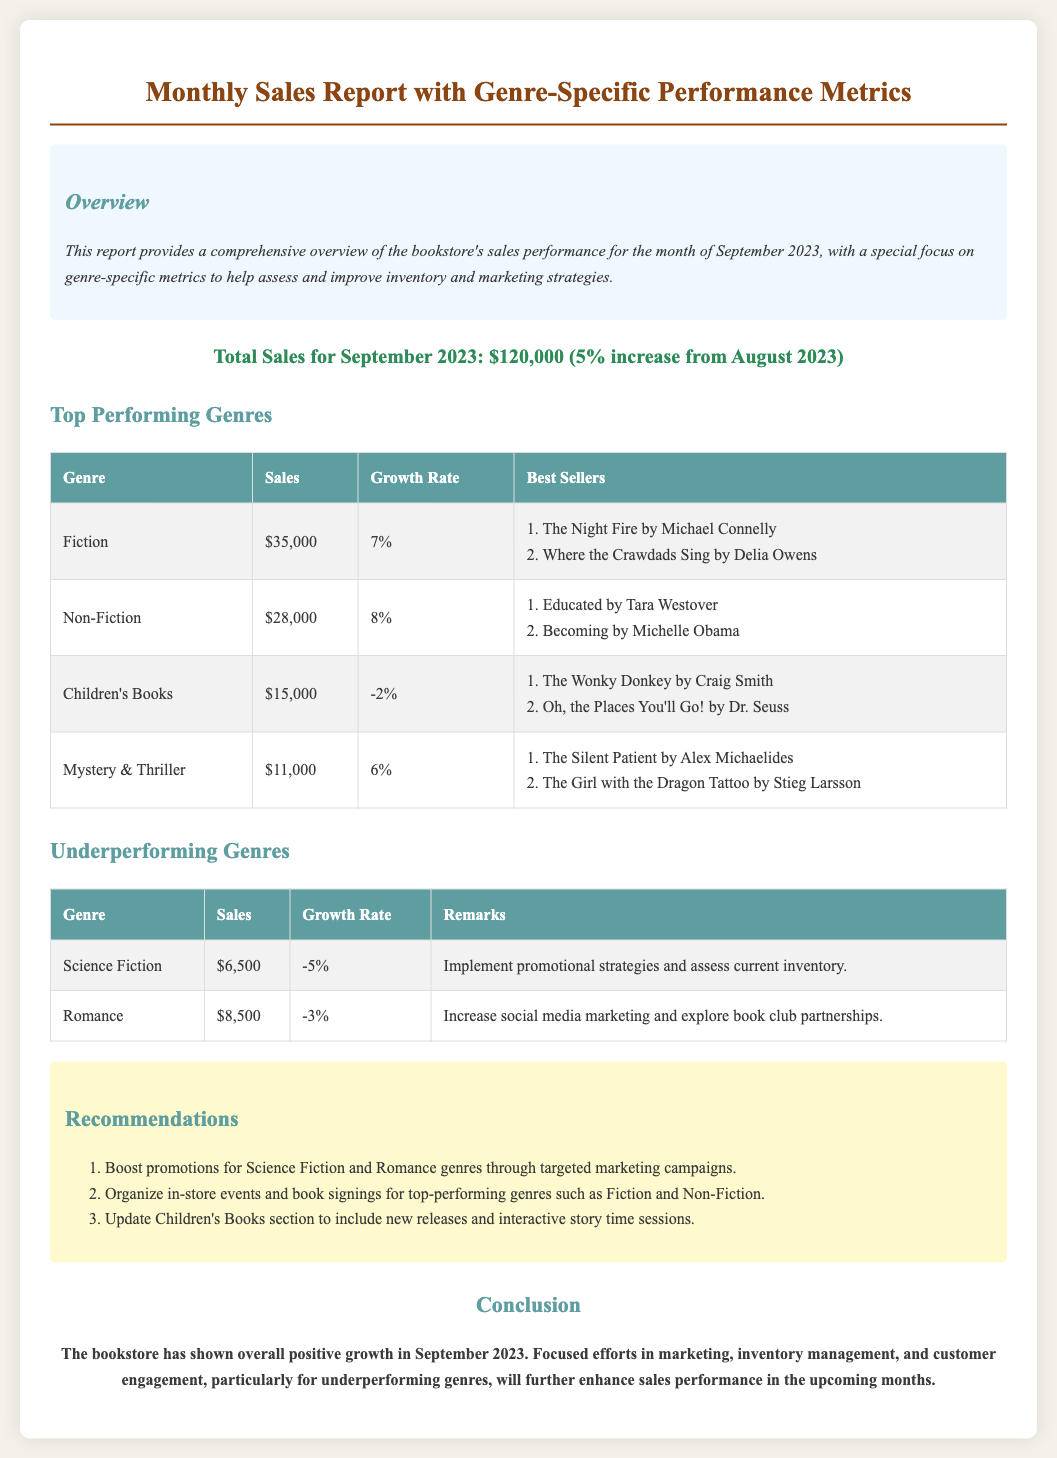What is the total sales for September 2023? The total sales is indicated in the document as a single figure reflecting the month’s earnings, which is $120,000.
Answer: $120,000 Which genre had the highest sales? The genre with the highest sales is directly mentioned in the document, which is Fiction with $35,000 in sales.
Answer: Fiction What was the growth rate for Non-Fiction? The growth rate for Non-Fiction is explicitly stated in the document, which is 8%.
Answer: 8% What are the best sellers in the Mystery & Thriller genre? The document lists the best sellers specifically for the Mystery & Thriller genre, which includes The Silent Patient and The Girl with the Dragon Tattoo.
Answer: The Silent Patient, The Girl with the Dragon Tattoo How much did Children's Books sales decrease? Children's Books sales are mentioned to have a growth rate of -2%, indicating a decrease in sales.
Answer: -2% What recommendations were made for the Science Fiction genre? The recommendations section provides insights on improving sales for underperforming genres, specifically mentioning promotional strategies for the Science Fiction genre.
Answer: Implement promotional strategies Which two genres experienced a decline in sales? The underperforming genres explicitly listed in the document are Science Fiction and Romance, both showing negative growth rates.
Answer: Science Fiction, Romance What is the tone of the conclusion regarding overall growth? The conclusion summarizes the sales performance in a positive light despite challenges, indicating the tone is optimistic about growth.
Answer: Positive Which best-selling book in Non-Fiction is recommended? The document lists two best sellers in Non-Fiction, including Educated by Tara Westover, specifying a recognized title for that genre.
Answer: Educated by Tara Westover 